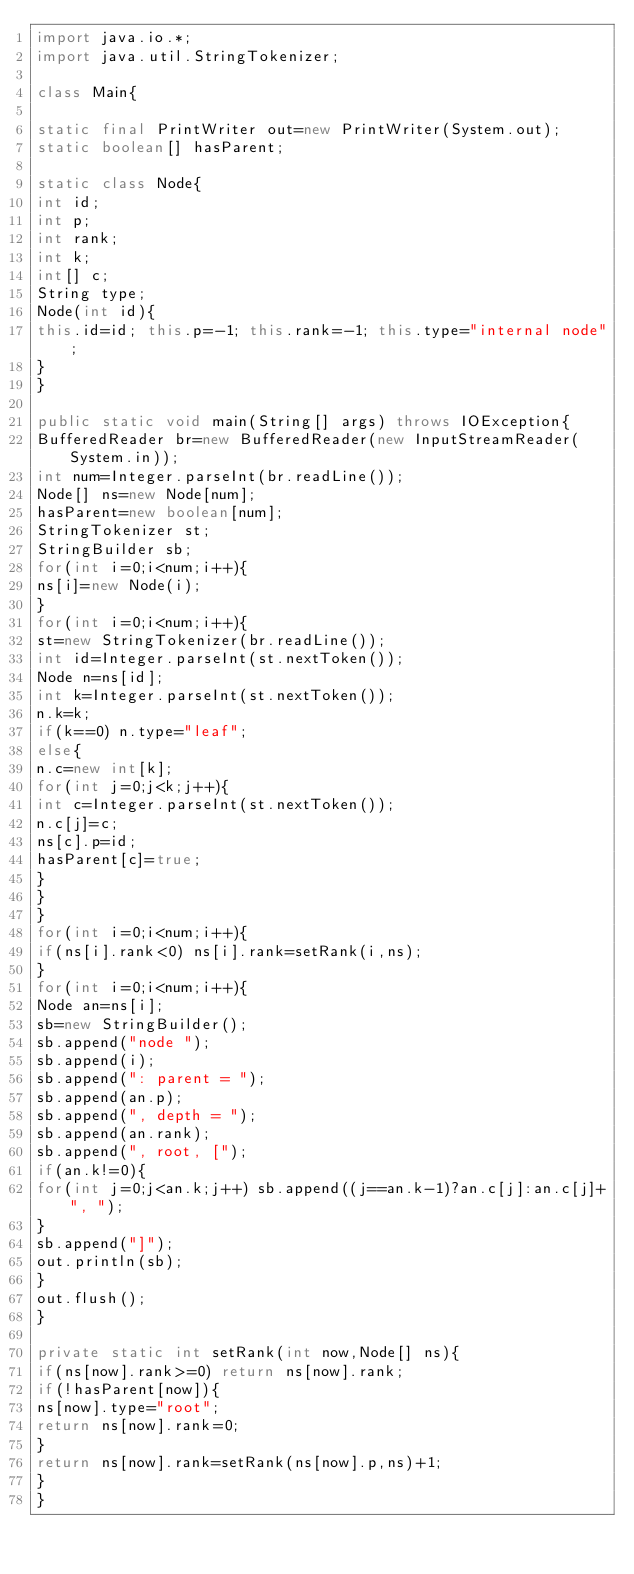<code> <loc_0><loc_0><loc_500><loc_500><_Java_>import java.io.*;
import java.util.StringTokenizer;

class Main{

static final PrintWriter out=new PrintWriter(System.out);
static boolean[] hasParent;

static class Node{
int id;
int p;
int rank;
int k;
int[] c;
String type;
Node(int id){
this.id=id; this.p=-1; this.rank=-1; this.type="internal node";
}
}

public static void main(String[] args) throws IOException{
BufferedReader br=new BufferedReader(new InputStreamReader(System.in));
int num=Integer.parseInt(br.readLine());
Node[] ns=new Node[num];
hasParent=new boolean[num];
StringTokenizer st;
StringBuilder sb;
for(int i=0;i<num;i++){
ns[i]=new Node(i);
}
for(int i=0;i<num;i++){
st=new StringTokenizer(br.readLine());
int id=Integer.parseInt(st.nextToken());
Node n=ns[id];
int k=Integer.parseInt(st.nextToken());
n.k=k;
if(k==0) n.type="leaf";
else{
n.c=new int[k];
for(int j=0;j<k;j++){
int c=Integer.parseInt(st.nextToken());
n.c[j]=c;
ns[c].p=id;
hasParent[c]=true;
}
}
}
for(int i=0;i<num;i++){
if(ns[i].rank<0) ns[i].rank=setRank(i,ns);
}
for(int i=0;i<num;i++){
Node an=ns[i];
sb=new StringBuilder();
sb.append("node ");
sb.append(i);
sb.append(": parent = ");
sb.append(an.p);
sb.append(", depth = ");
sb.append(an.rank);
sb.append(", root, [");
if(an.k!=0){
for(int j=0;j<an.k;j++) sb.append((j==an.k-1)?an.c[j]:an.c[j]+", ");
}
sb.append("]");
out.println(sb);
}
out.flush();
}

private static int setRank(int now,Node[] ns){
if(ns[now].rank>=0) return ns[now].rank;
if(!hasParent[now]){
ns[now].type="root";
return ns[now].rank=0;
}
return ns[now].rank=setRank(ns[now].p,ns)+1;
}
}</code> 